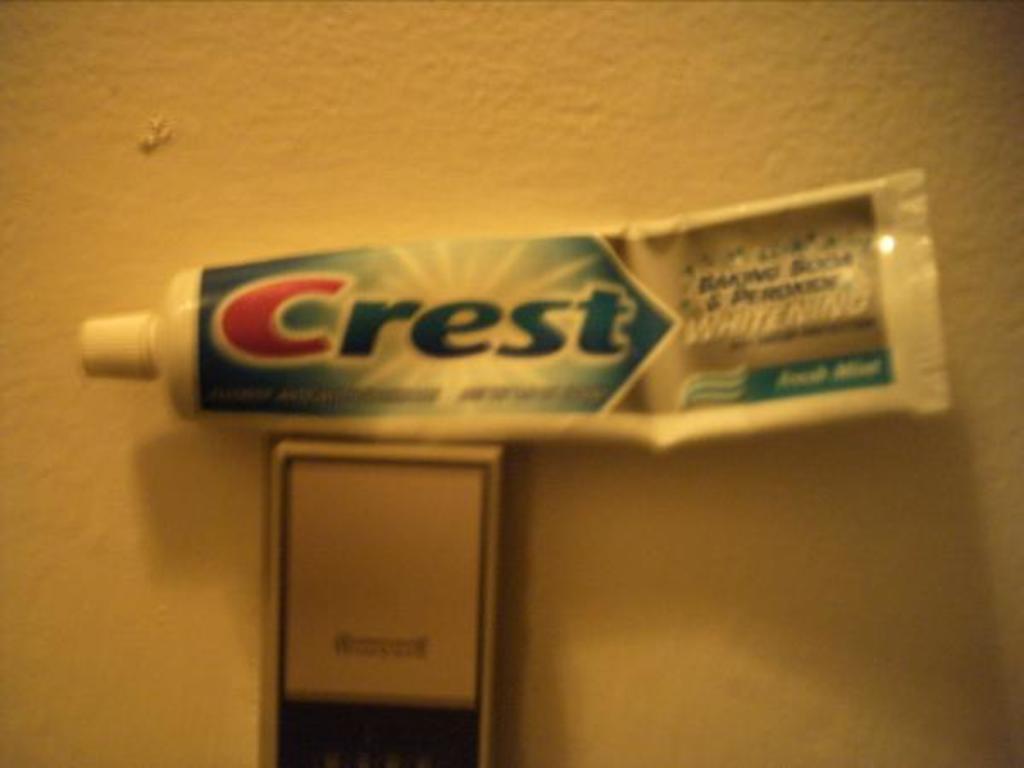What brand is the toothpaste?
Keep it short and to the point. Crest. What does the toothpaste claim to do?
Give a very brief answer. Whitening. 